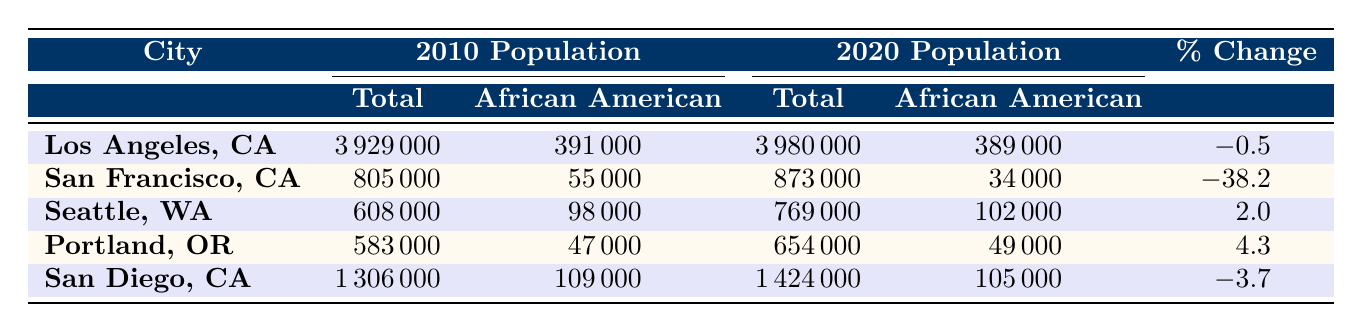What was the African American population in Los Angeles, CA in 2010? According to the table, the African American population in Los Angeles, CA in 2010 was listed as 391,000.
Answer: 391000 Which city experienced the largest percentage decrease in the African American population from 2010 to 2020? The table shows that San Francisco, CA had the largest percentage decrease at -38.2%.
Answer: San Francisco, CA What was the total population of Seattle, WA in 2020? The table indicates that the total population of Seattle, WA in 2020 was 769,000.
Answer: 769000 What is the difference in the African American population between 2010 and 2020 for San Diego, CA? In 2010, the African American population in San Diego, CA was 109,000, and in 2020 it was 105,000. The difference is 109,000 - 105,000 = 4,000.
Answer: 4000 Which city had an increase in the African American population from 2010 to 2020? The table reveals that Seattle, WA had an increase, with the population rising from 98,000 in 2010 to 102,000 in 2020, a change of +4,000.
Answer: Seattle, WA What was the total African American population across all the cities listed in 2020? Adding the African American populations for 2020: 389,000 (Los Angeles) + 34,000 (San Francisco) + 102,000 (Seattle) + 49,000 (Portland) + 105,000 (San Diego) gives a total of 679,000.
Answer: 679000 Which city had the highest total population in 2020? According to the table, Los Angeles, CA had the highest total population in 2020 at 3,980,000.
Answer: Los Angeles, CA Is the African American population in Portland, OR increasing or decreasing from 2010 to 2020? The table shows that the population in Portland, OR increased from 47,000 in 2010 to 49,000 in 2020, indicating an increase.
Answer: Increasing What is the average percentage change of the African American populations across all cities from 2010 to 2020? The percentage changes are: -0.5 (Los Angeles), -38.2 (San Francisco), 2.0 (Seattle), 4.3 (Portland), and -3.7 (San Diego). Their average is calculated as (-0.5 - 38.2 + 2.0 + 4.3 - 3.7) / 5 = -7.82%.
Answer: -7.82 Which two cities had a positive change in the African American population? The cities with a positive change are Seattle, WA (+2.0%) and Portland, OR (+4.3%).
Answer: Seattle, WA and Portland, OR If you combine the African American populations of San Francisco, CA and San Diego, CA for 2020, what would that total be? The 2020 populations are 34,000 for San Francisco and 105,000 for San Diego, so the total is 34,000 + 105,000 = 139,000.
Answer: 139000 